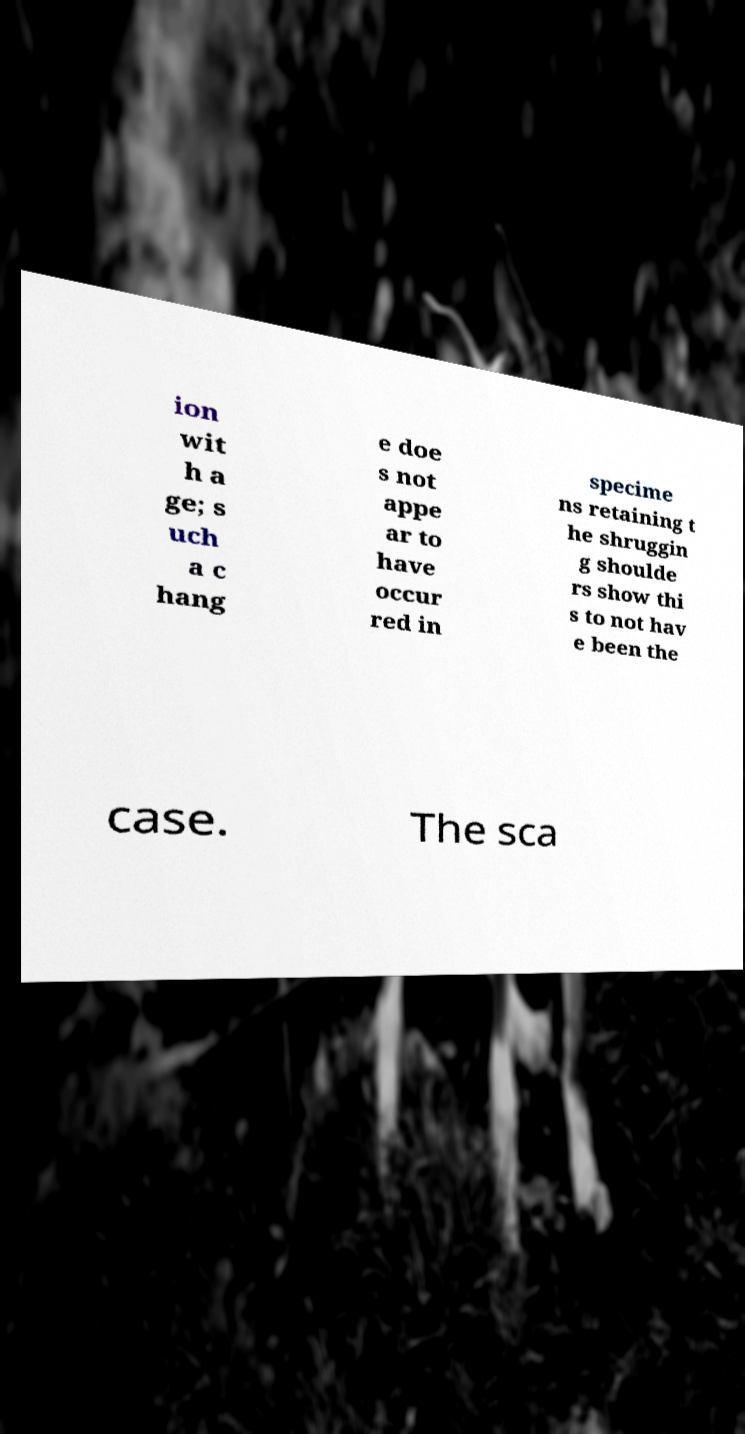What messages or text are displayed in this image? I need them in a readable, typed format. ion wit h a ge; s uch a c hang e doe s not appe ar to have occur red in specime ns retaining t he shruggin g shoulde rs show thi s to not hav e been the case. The sca 